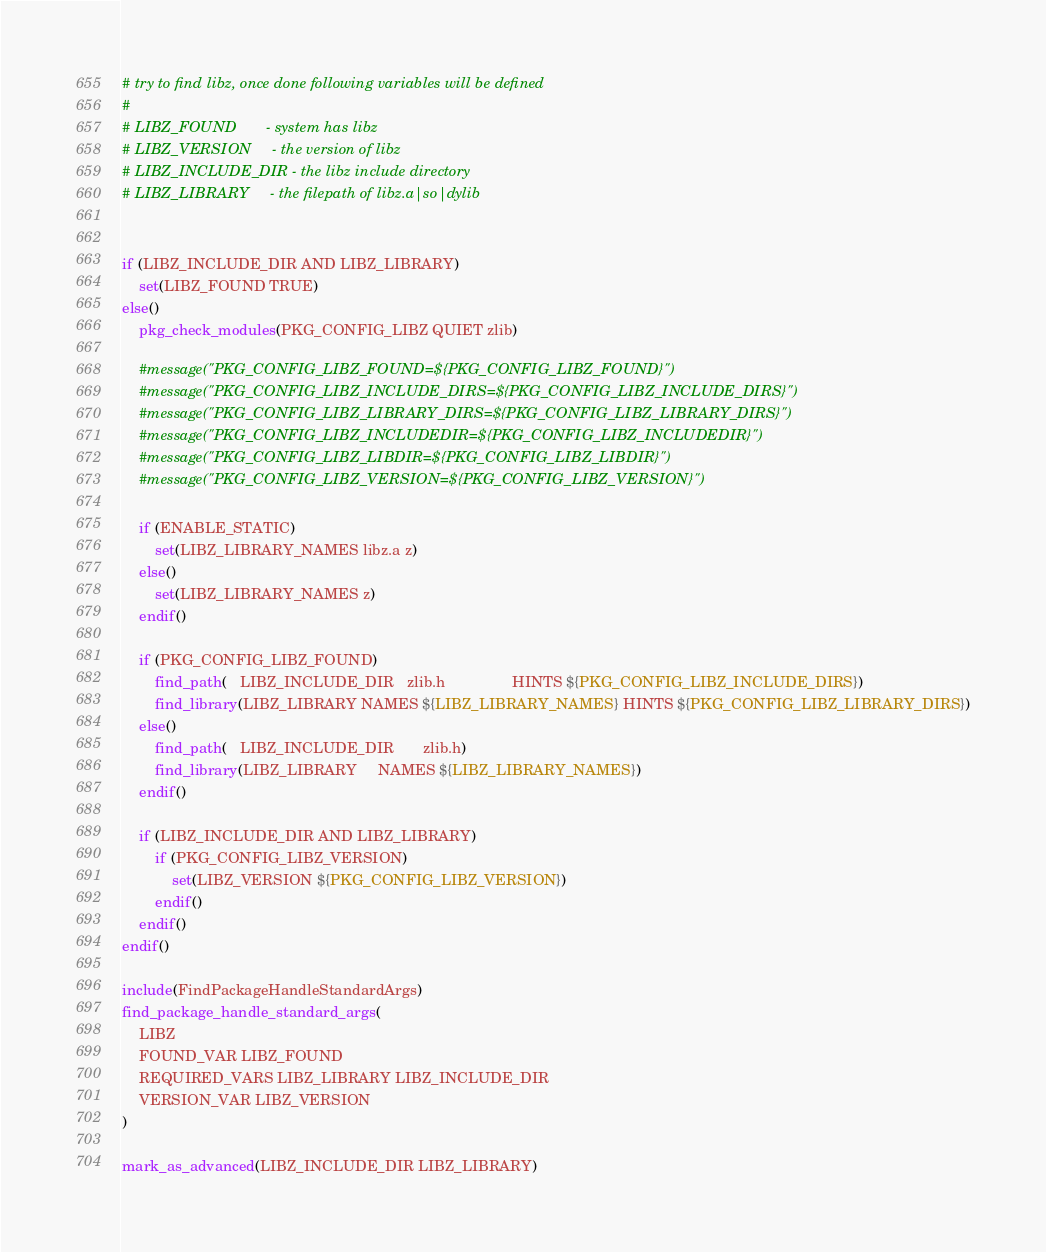Convert code to text. <code><loc_0><loc_0><loc_500><loc_500><_CMake_># try to find libz, once done following variables will be defined
#
# LIBZ_FOUND       - system has libz
# LIBZ_VERSION     - the version of libz
# LIBZ_INCLUDE_DIR - the libz include directory
# LIBZ_LIBRARY     - the filepath of libz.a|so|dylib


if (LIBZ_INCLUDE_DIR AND LIBZ_LIBRARY)
    set(LIBZ_FOUND TRUE)
else()
    pkg_check_modules(PKG_CONFIG_LIBZ QUIET zlib)

    #message("PKG_CONFIG_LIBZ_FOUND=${PKG_CONFIG_LIBZ_FOUND}")
    #message("PKG_CONFIG_LIBZ_INCLUDE_DIRS=${PKG_CONFIG_LIBZ_INCLUDE_DIRS}")
    #message("PKG_CONFIG_LIBZ_LIBRARY_DIRS=${PKG_CONFIG_LIBZ_LIBRARY_DIRS}")
    #message("PKG_CONFIG_LIBZ_INCLUDEDIR=${PKG_CONFIG_LIBZ_INCLUDEDIR}")
    #message("PKG_CONFIG_LIBZ_LIBDIR=${PKG_CONFIG_LIBZ_LIBDIR}")
    #message("PKG_CONFIG_LIBZ_VERSION=${PKG_CONFIG_LIBZ_VERSION}")
     
    if (ENABLE_STATIC)
        set(LIBZ_LIBRARY_NAMES libz.a z)
    else()
        set(LIBZ_LIBRARY_NAMES z)
    endif()

    if (PKG_CONFIG_LIBZ_FOUND)
        find_path(   LIBZ_INCLUDE_DIR   zlib.h                HINTS ${PKG_CONFIG_LIBZ_INCLUDE_DIRS})
        find_library(LIBZ_LIBRARY NAMES ${LIBZ_LIBRARY_NAMES} HINTS ${PKG_CONFIG_LIBZ_LIBRARY_DIRS})
    else()
        find_path(   LIBZ_INCLUDE_DIR       zlib.h)
        find_library(LIBZ_LIBRARY     NAMES ${LIBZ_LIBRARY_NAMES})
    endif()

    if (LIBZ_INCLUDE_DIR AND LIBZ_LIBRARY)
        if (PKG_CONFIG_LIBZ_VERSION)
            set(LIBZ_VERSION ${PKG_CONFIG_LIBZ_VERSION})
        endif()
    endif()
endif()

include(FindPackageHandleStandardArgs)
find_package_handle_standard_args(
    LIBZ
    FOUND_VAR LIBZ_FOUND
    REQUIRED_VARS LIBZ_LIBRARY LIBZ_INCLUDE_DIR
    VERSION_VAR LIBZ_VERSION
)

mark_as_advanced(LIBZ_INCLUDE_DIR LIBZ_LIBRARY)
</code> 